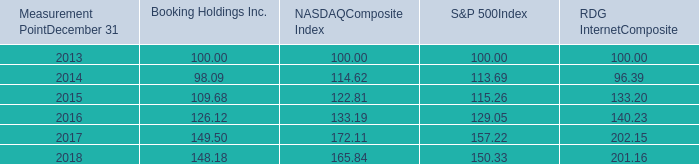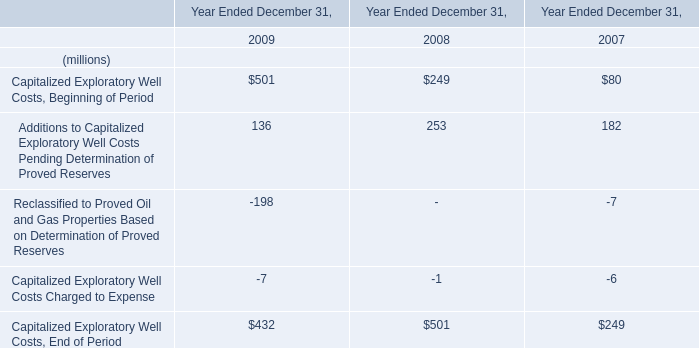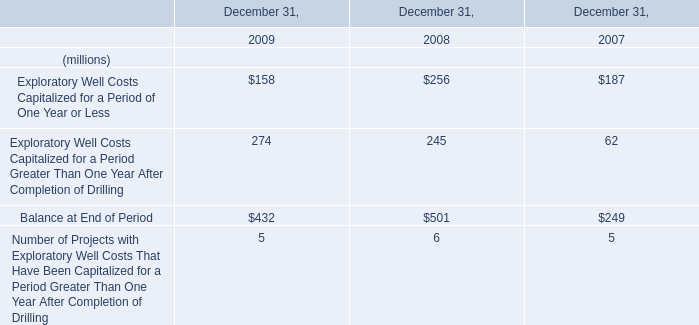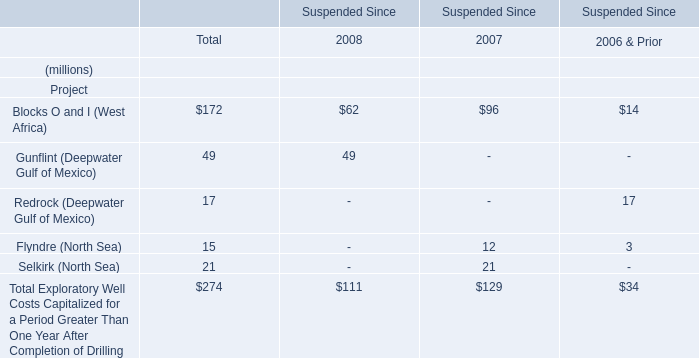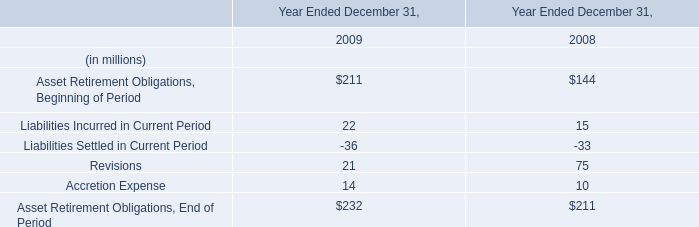Which year is Capitalized Exploratory Well Costs Charged to Expense the highest? 
Answer: 2008. 